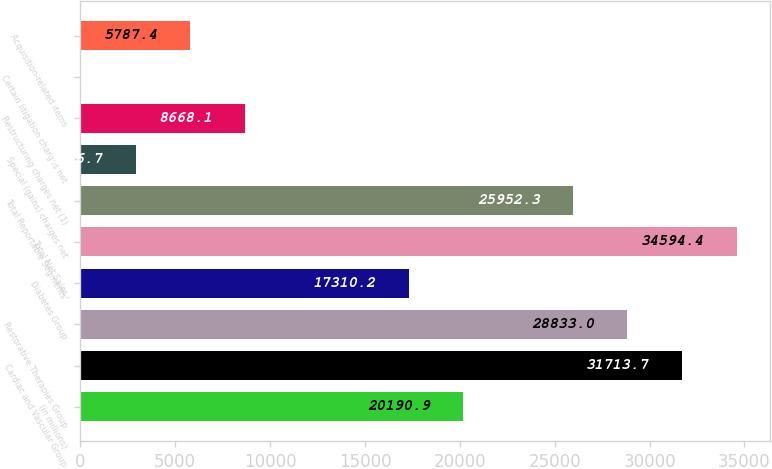<chart> <loc_0><loc_0><loc_500><loc_500><bar_chart><fcel>(in millions)<fcel>Cardiac and Vascular Group<fcel>Restorative Therapies Group<fcel>Diabetes Group<fcel>Total Net Sales<fcel>Total Reportable Segments'<fcel>Special (gains) charges net<fcel>Restructuring charges net (1)<fcel>Certain litigation charges net<fcel>Acquisition-related items<nl><fcel>20190.9<fcel>31713.7<fcel>28833<fcel>17310.2<fcel>34594.4<fcel>25952.3<fcel>2906.7<fcel>8668.1<fcel>26<fcel>5787.4<nl></chart> 